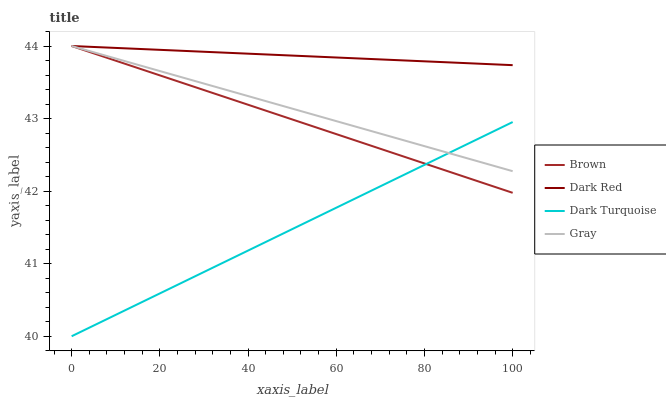Does Dark Turquoise have the minimum area under the curve?
Answer yes or no. Yes. Does Dark Red have the maximum area under the curve?
Answer yes or no. Yes. Does Gray have the minimum area under the curve?
Answer yes or no. No. Does Gray have the maximum area under the curve?
Answer yes or no. No. Is Brown the smoothest?
Answer yes or no. Yes. Is Gray the roughest?
Answer yes or no. Yes. Is Dark Turquoise the smoothest?
Answer yes or no. No. Is Dark Turquoise the roughest?
Answer yes or no. No. Does Dark Turquoise have the lowest value?
Answer yes or no. Yes. Does Gray have the lowest value?
Answer yes or no. No. Does Dark Red have the highest value?
Answer yes or no. Yes. Does Dark Turquoise have the highest value?
Answer yes or no. No. Is Dark Turquoise less than Dark Red?
Answer yes or no. Yes. Is Dark Red greater than Dark Turquoise?
Answer yes or no. Yes. Does Gray intersect Dark Red?
Answer yes or no. Yes. Is Gray less than Dark Red?
Answer yes or no. No. Is Gray greater than Dark Red?
Answer yes or no. No. Does Dark Turquoise intersect Dark Red?
Answer yes or no. No. 